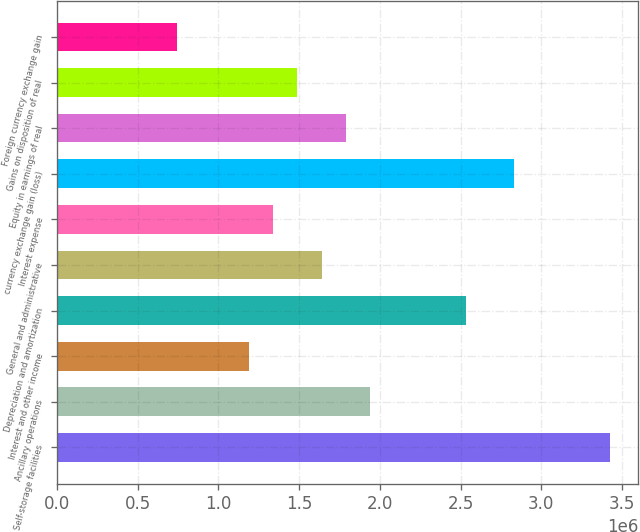<chart> <loc_0><loc_0><loc_500><loc_500><bar_chart><fcel>Self-storage facilities<fcel>Ancillary operations<fcel>Interest and other income<fcel>Depreciation and amortization<fcel>General and administrative<fcel>Interest expense<fcel>currency exchange gain (loss)<fcel>Equity in earnings of real<fcel>Gains on disposition of real<fcel>Foreign currency exchange gain<nl><fcel>3.42767e+06<fcel>1.93738e+06<fcel>1.19223e+06<fcel>2.53349e+06<fcel>1.63932e+06<fcel>1.34126e+06<fcel>2.83155e+06<fcel>1.78835e+06<fcel>1.49029e+06<fcel>745147<nl></chart> 